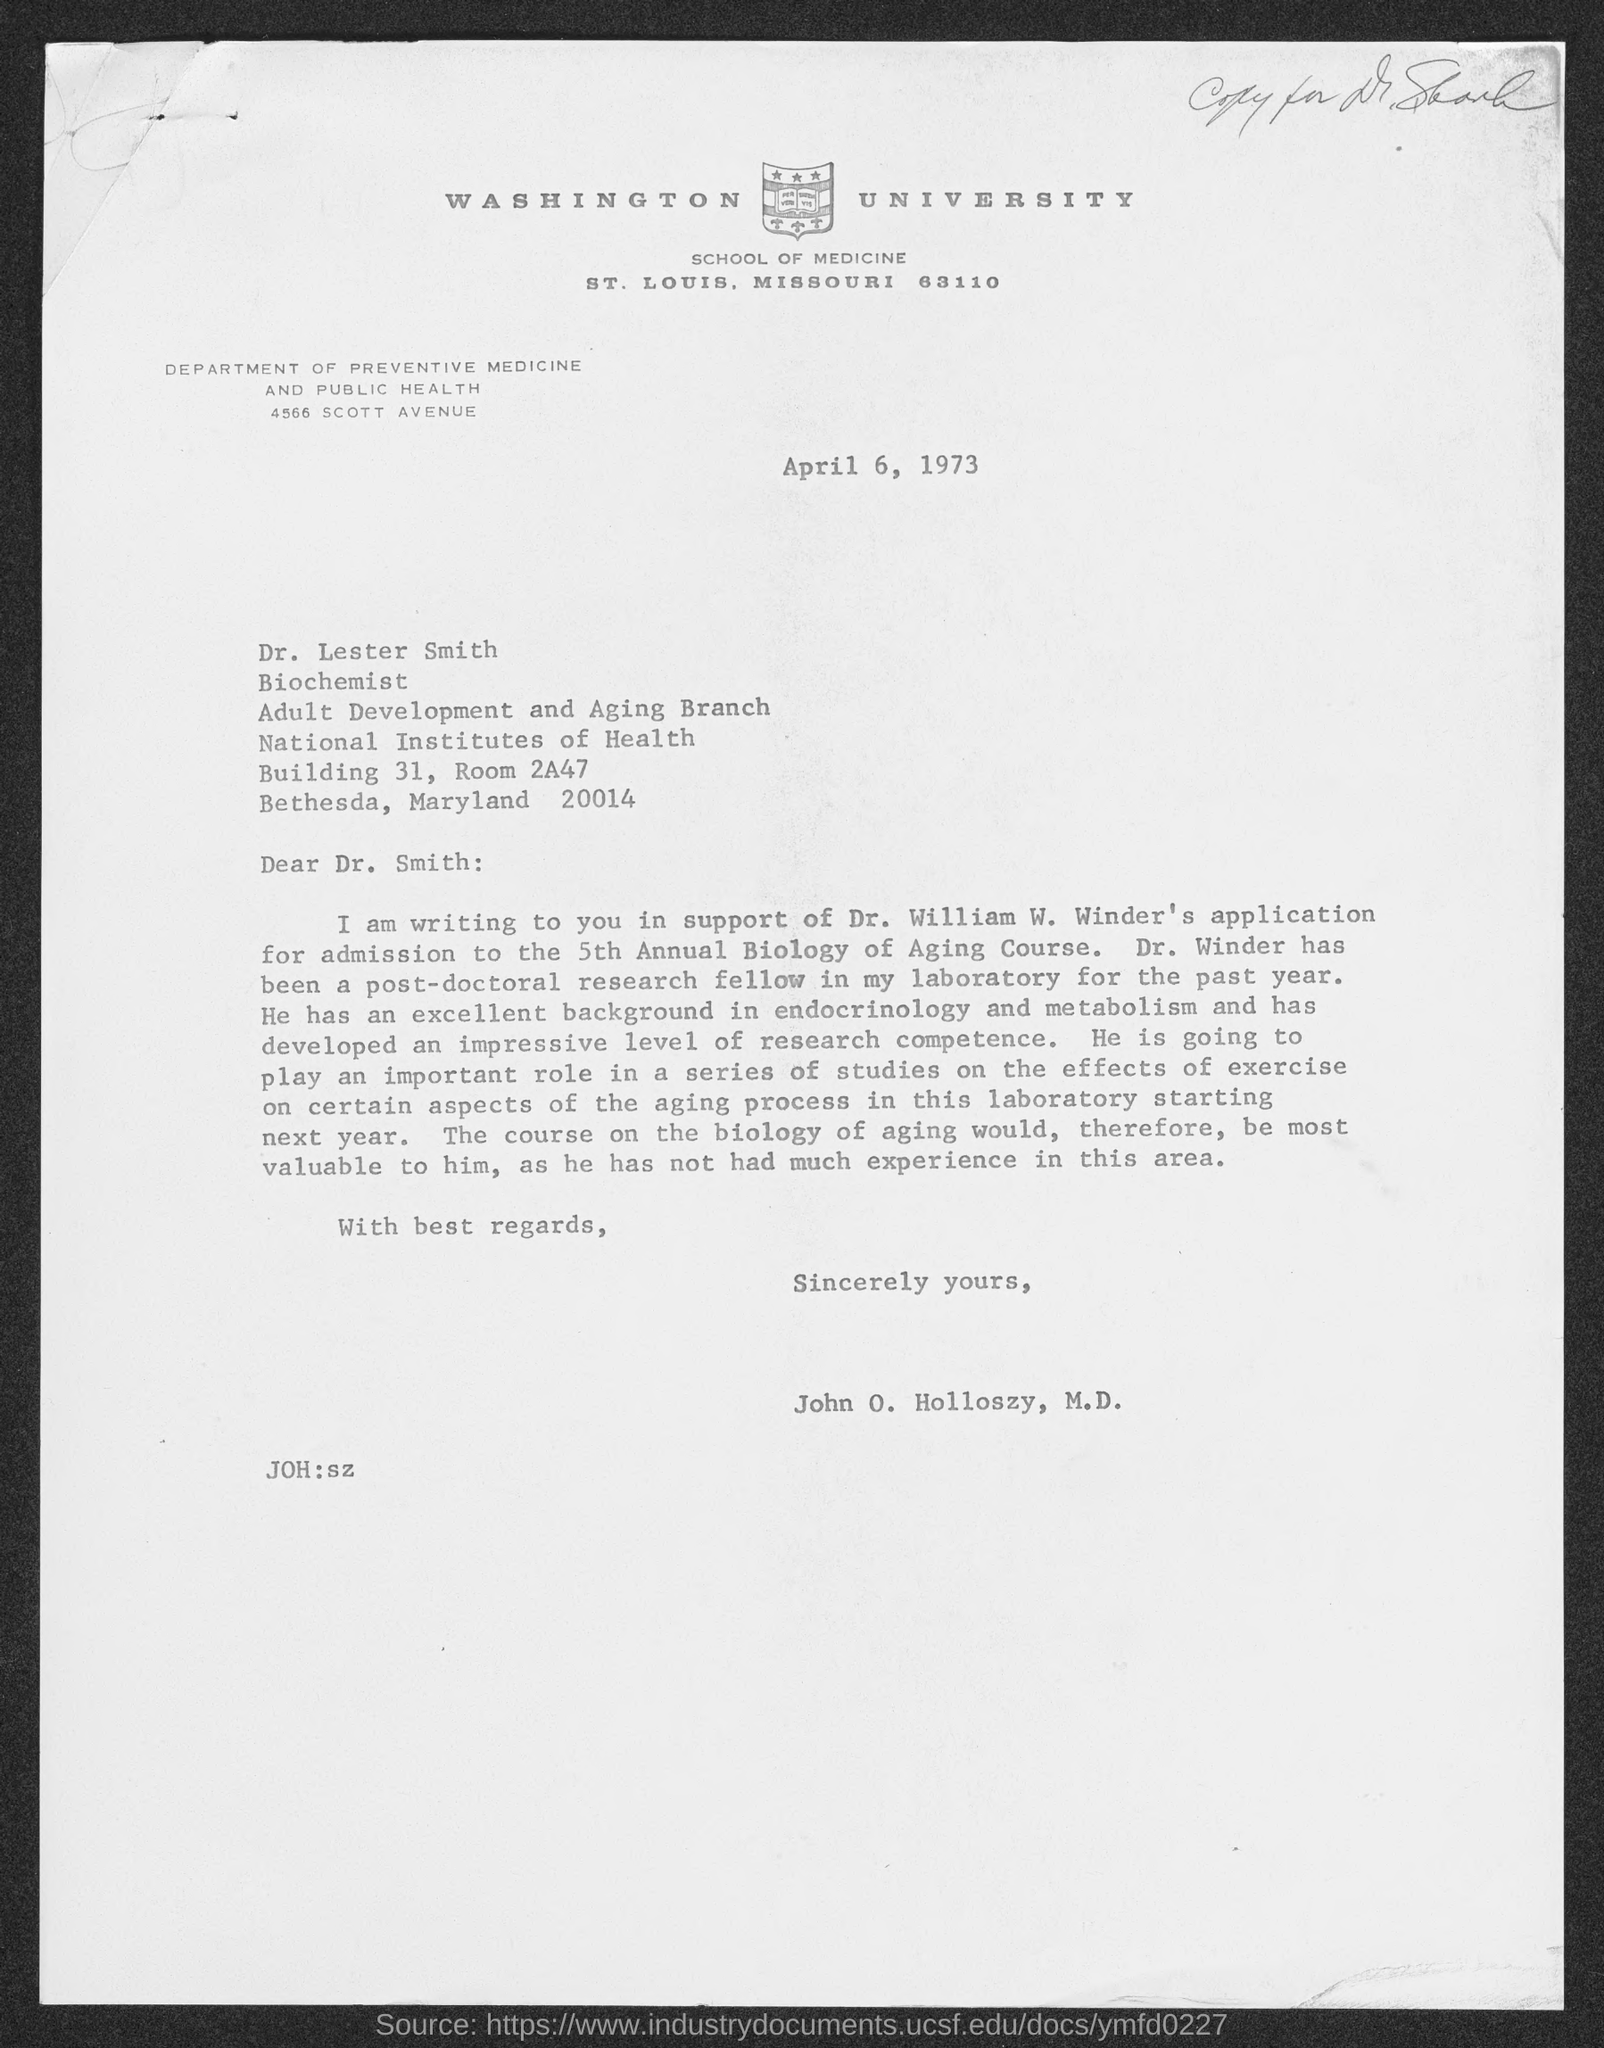Draw attention to some important aspects in this diagram. The salutation of the letter is "Dear Dr. Smith:... The date is April 6, 1973. 